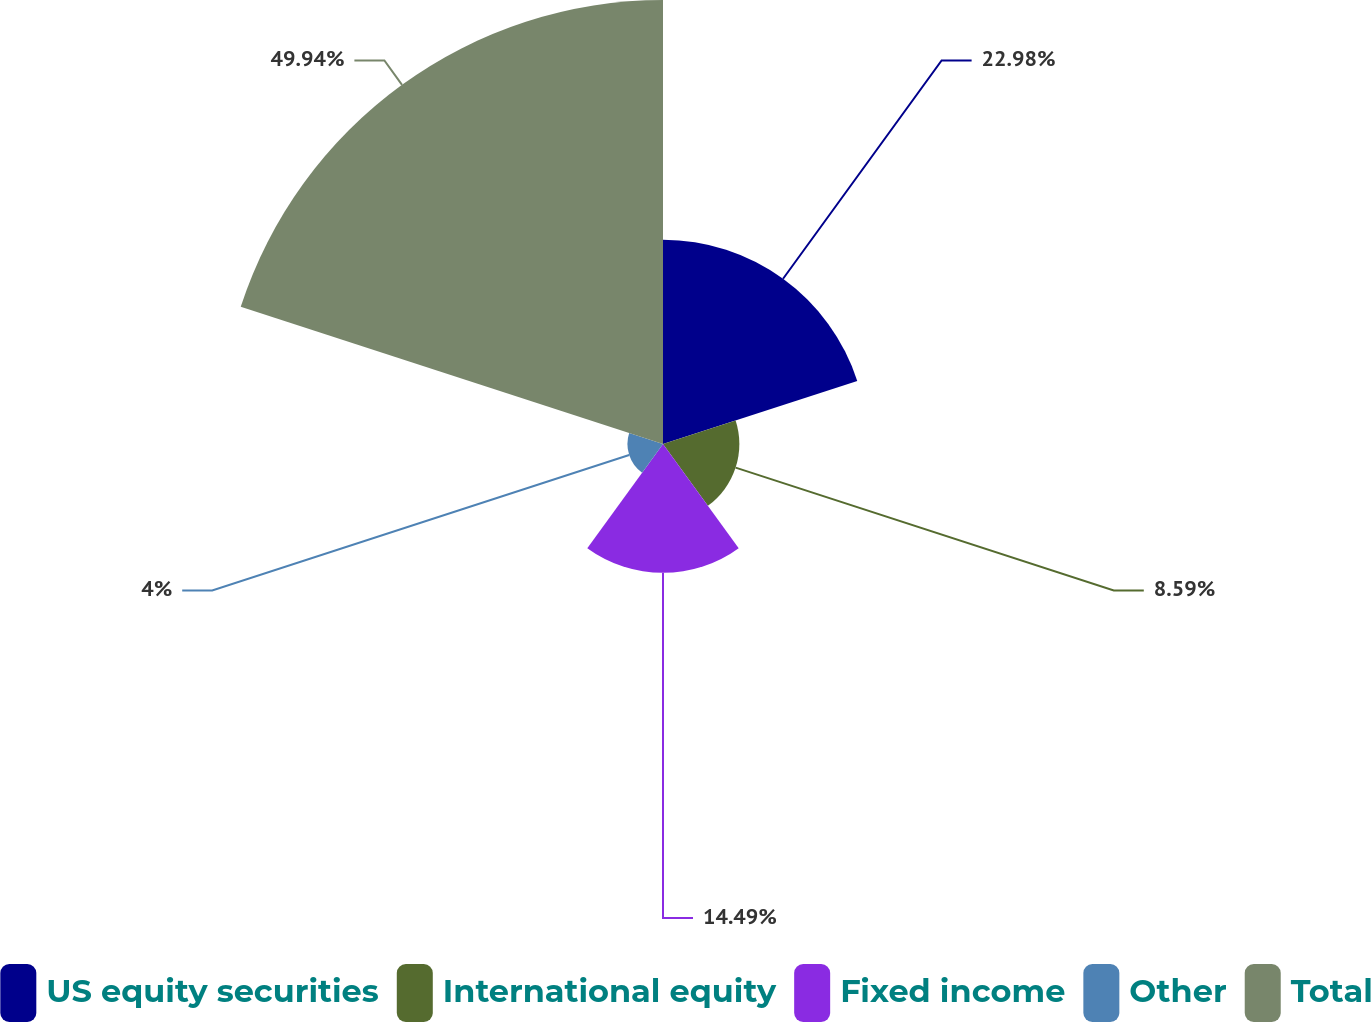Convert chart. <chart><loc_0><loc_0><loc_500><loc_500><pie_chart><fcel>US equity securities<fcel>International equity<fcel>Fixed income<fcel>Other<fcel>Total<nl><fcel>22.98%<fcel>8.59%<fcel>14.49%<fcel>4.0%<fcel>49.95%<nl></chart> 